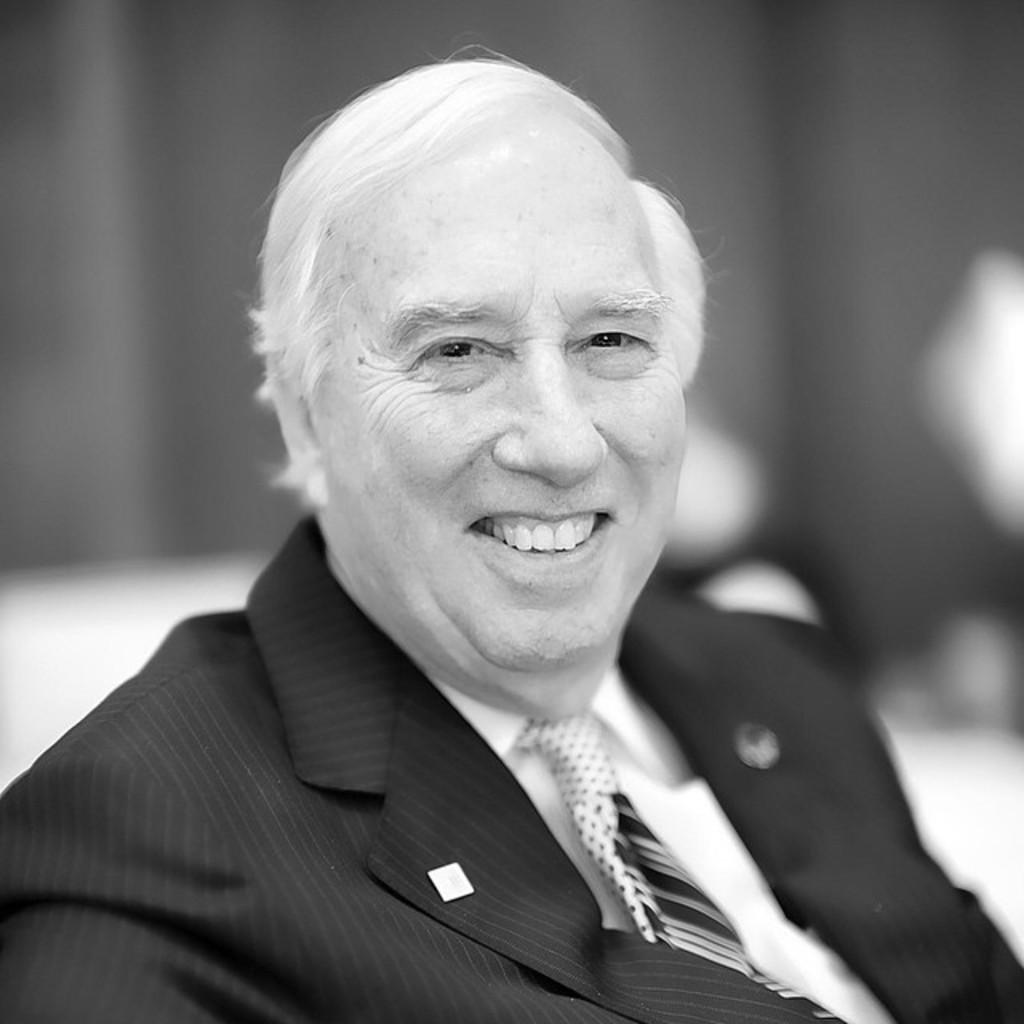What is the color scheme of the image? The image is black and white. What is the person in the image doing? The person is sitting on a chair in the image. What is the facial expression of the person? The person is wearing a smile. What can be seen in the background of the image? There is a wall in the background of the image. How many thumbs can be seen on the person's hands in the image? There is no information about the person's thumbs in the image, as it is black and white and only shows the person sitting on a chair with a smile. 